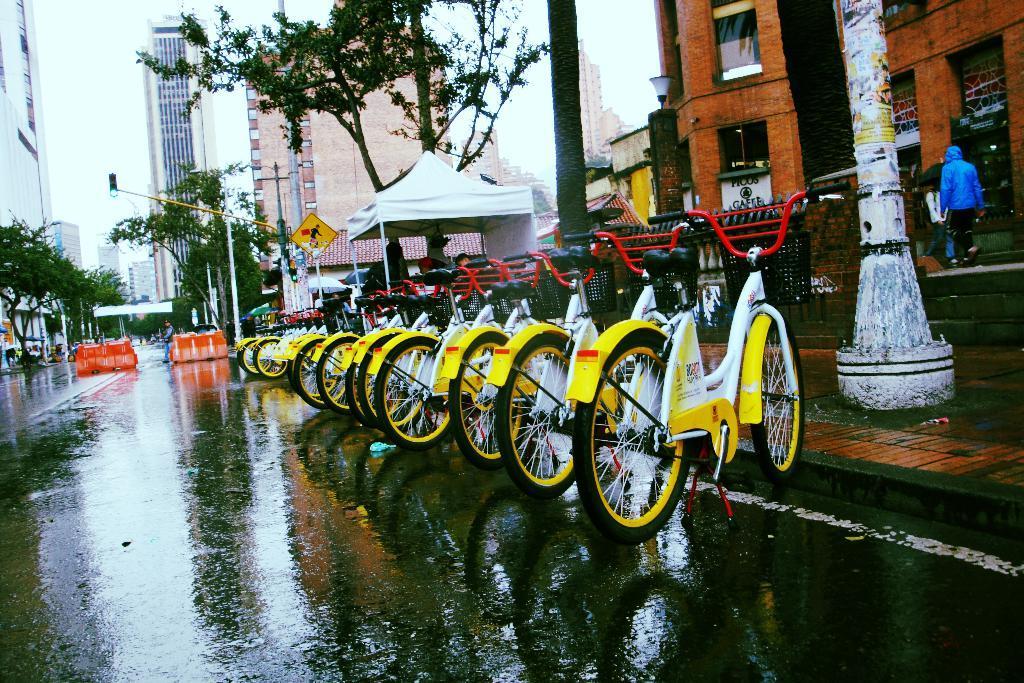Please provide a concise description of this image. In this image, we can see few bicycles are parked on the road. Here the road is wet. Background we can see buildings, trees, poles, tent, traffic signals, boards, wall, few people, sky and some objects. 